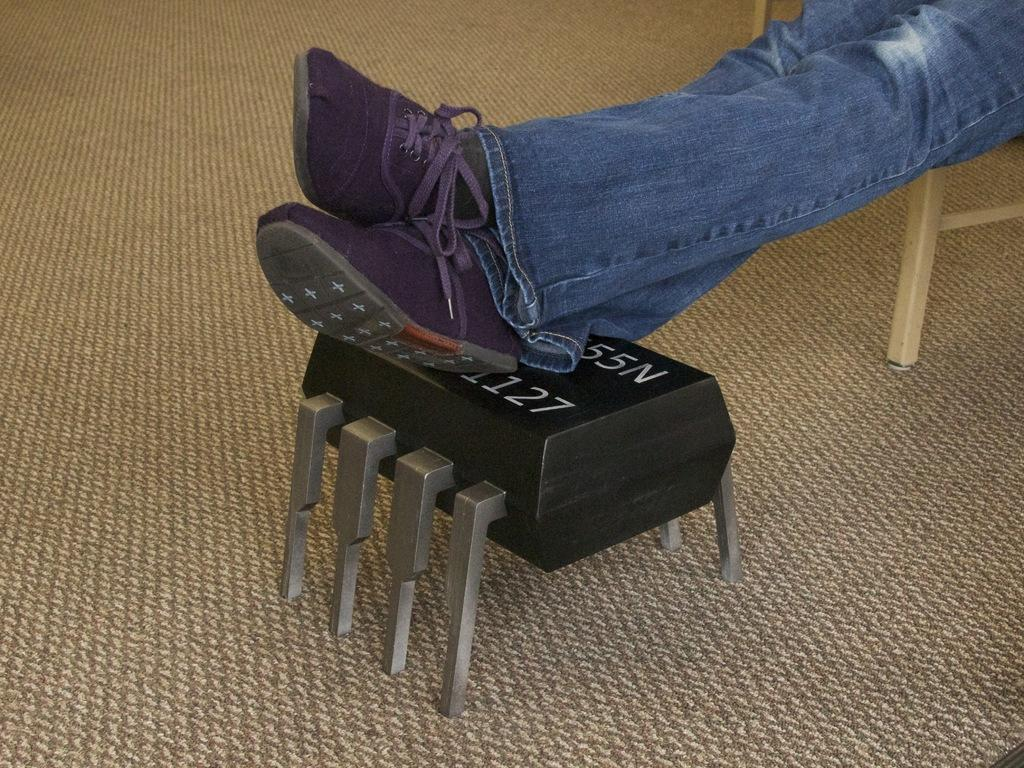What part of a person can be seen in the image? One person's legs are visible in the image. What is the person doing with their legs? The person is keeping their legs on a box. What type of surface is under the person's legs? There is a floor in the image. What can be seen in the background of the image? There are chairs in the background of the image. What type of shade is being used to protect the person's thumb in the image? There is no shade or thumb present in the image; only the person's legs and a box can be seen. 